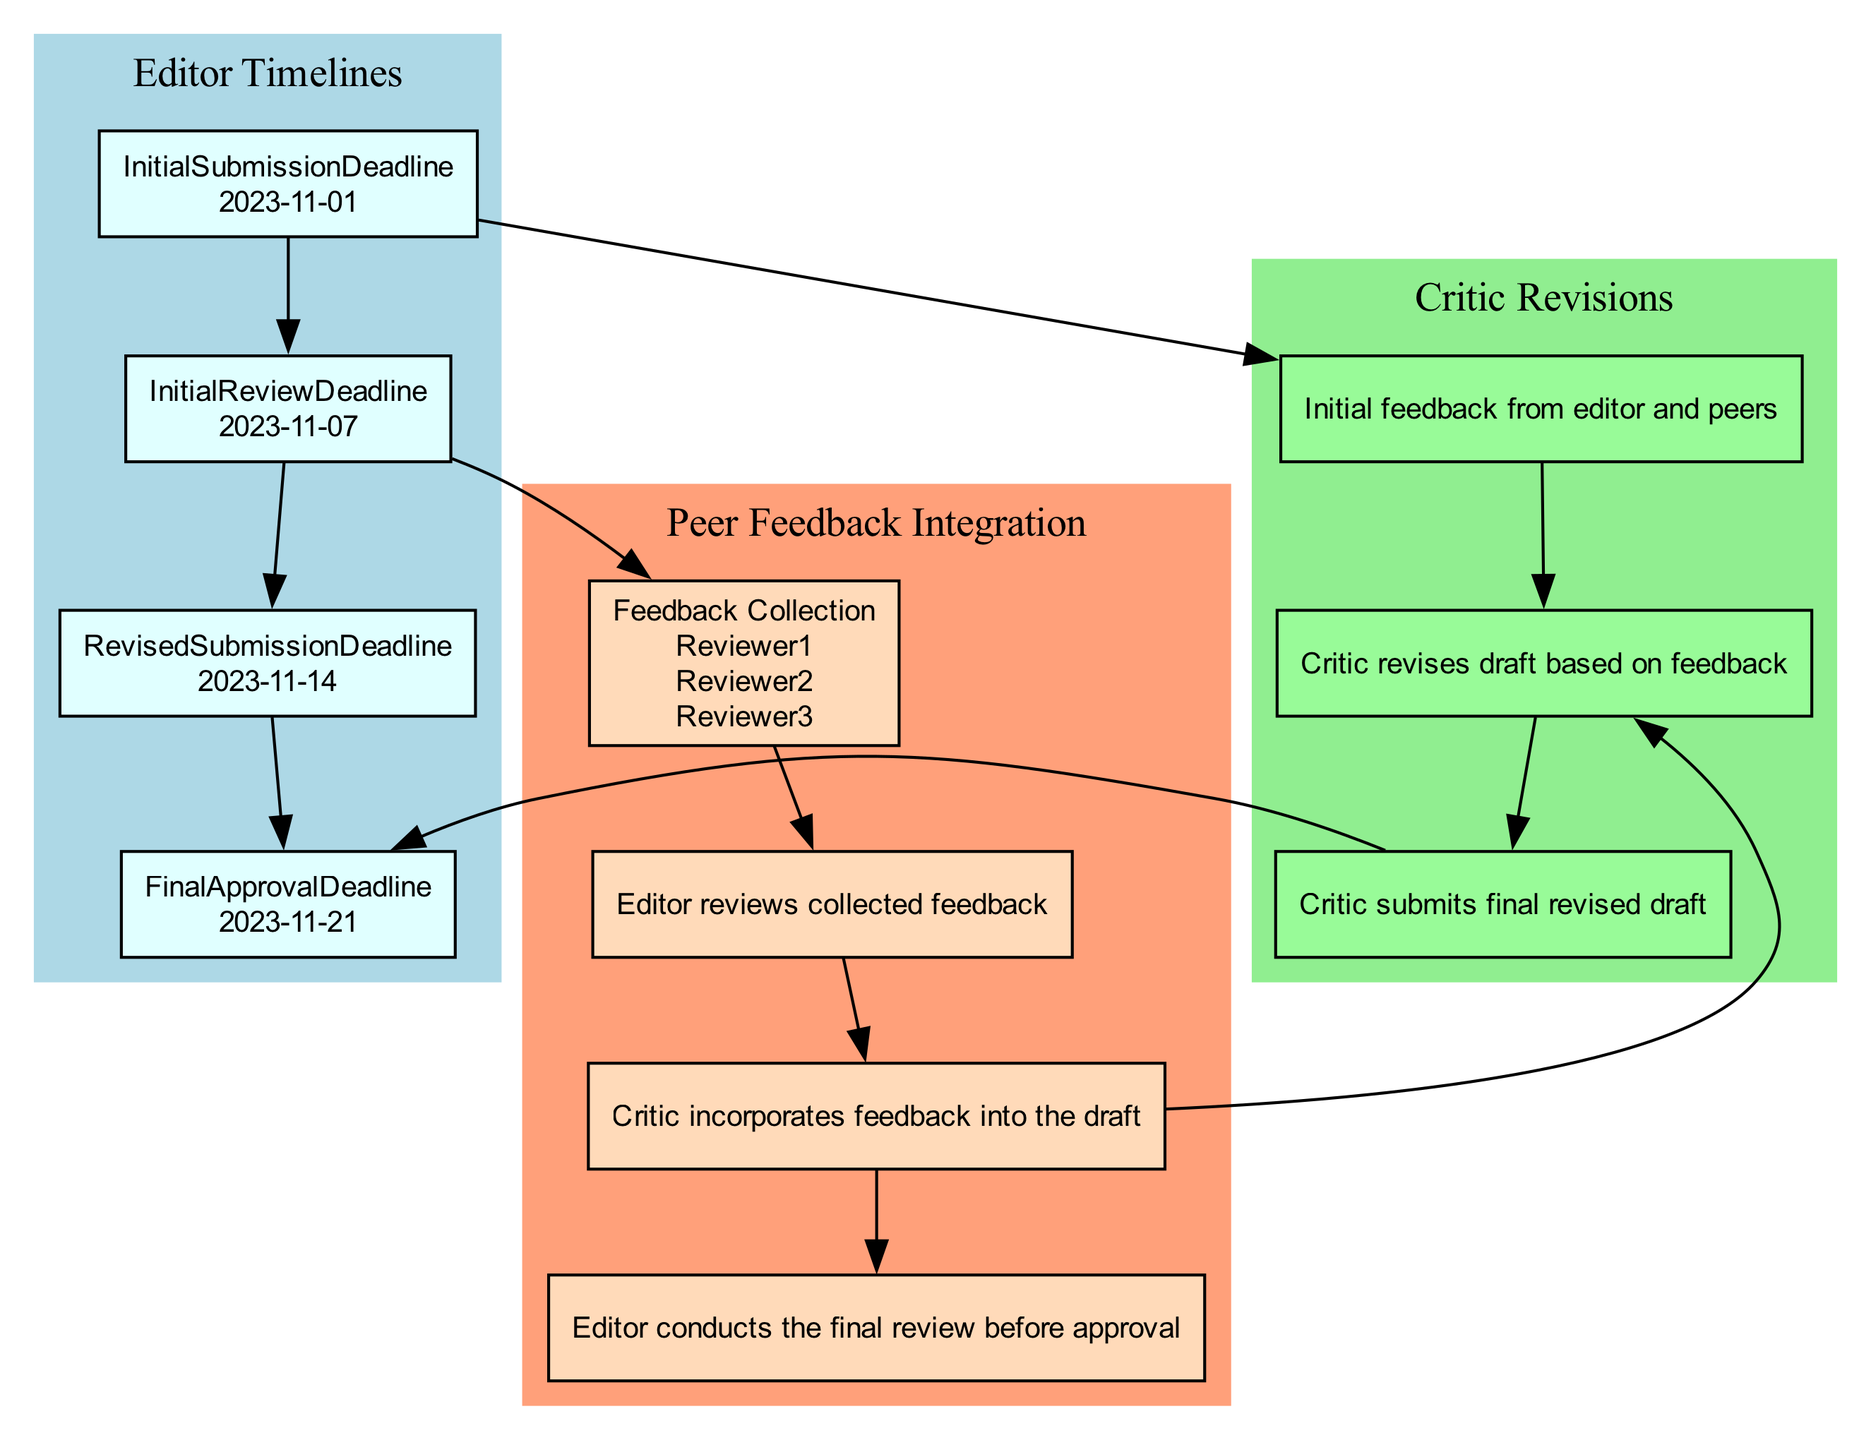What is the deadline for the initial submission? The diagram indicates the initial submission deadline is specifically marked as “2023-11-01” under the Editor Timelines section.
Answer: 2023-11-01 Who submits the final revised draft? According to the Critic Revisions section, the final entity responsible for submitting the final revised draft is the critic, which is stated explicitly in the node labeled 'Final Submission'.
Answer: Critic How many peer reviewers are involved in the feedback collection? The Feedback Collection node lists three specific peer reviewers: Reviewer1, Reviewer2, and Reviewer3. This is a straightforward count of the names given in the node.
Answer: 3 What happens immediately after the Feedback Review? Following the Feedback Review node, the next step in the diagram is the Feedback Incorporation node which indicates that the next action involves the critic integrating feedback into the draft.
Answer: Feedback Incorporation What is the final approval deadline? The diagram clearly indicates that the final approval deadline for the submission is stated as “2023-11-21” in the Editor Timelines section, marking the end of the approval process.
Answer: 2023-11-21 What is one action the critic must take before submitting the final draft? The diagram shows that before submitting the final draft, the critic must first revise the draft based on initial feedback, a step detailed in the Critic Revisions section.
Answer: Draft Revisions Which two nodes are connected to the Initial Review Deadline? The diagram outlines that the Initial Review Deadline is connected to two actions: the Feedback Collection and Revised Submission, indicating the subsequent process involving peer feedback collection and revision submission.
Answer: Feedback Collection, Revised Submission What color represents the Critic Revisions section in the diagram? The Critic Revisions section is filled with a light green color, which is visually distinct in the block diagram and readily identifiable.
Answer: Light green What is the relation between the Final Submission and the Final Approval Deadline? The diagram shows a directed edge from the Final Submission node to the Final Approval Deadline node, indicating that the final submission directly leads to the final approval process.
Answer: Final Submission -> Final Approval Deadline 